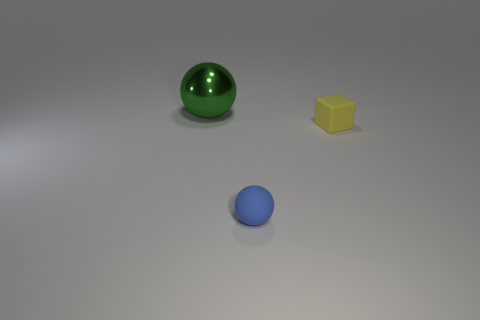Add 3 large brown rubber cylinders. How many objects exist? 6 Subtract all balls. How many objects are left? 1 Add 2 metallic objects. How many metallic objects are left? 3 Add 3 tiny metallic balls. How many tiny metallic balls exist? 3 Subtract 0 cyan cylinders. How many objects are left? 3 Subtract all tiny yellow things. Subtract all matte spheres. How many objects are left? 1 